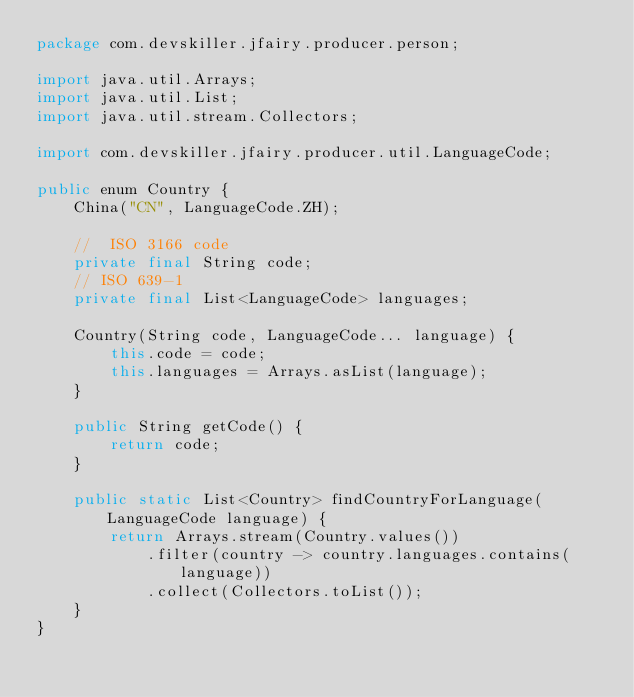Convert code to text. <code><loc_0><loc_0><loc_500><loc_500><_Java_>package com.devskiller.jfairy.producer.person;

import java.util.Arrays;
import java.util.List;
import java.util.stream.Collectors;

import com.devskiller.jfairy.producer.util.LanguageCode;

public enum Country {
	China("CN", LanguageCode.ZH);

	//	ISO 3166 code
	private final String code;
	// ISO 639-1
	private final List<LanguageCode> languages;

	Country(String code, LanguageCode... language) {
		this.code = code;
		this.languages = Arrays.asList(language);
	}

	public String getCode() {
		return code;
	}

	public static List<Country> findCountryForLanguage(LanguageCode language) {
		return Arrays.stream(Country.values())
			.filter(country -> country.languages.contains(language))
			.collect(Collectors.toList());
	}
}
</code> 